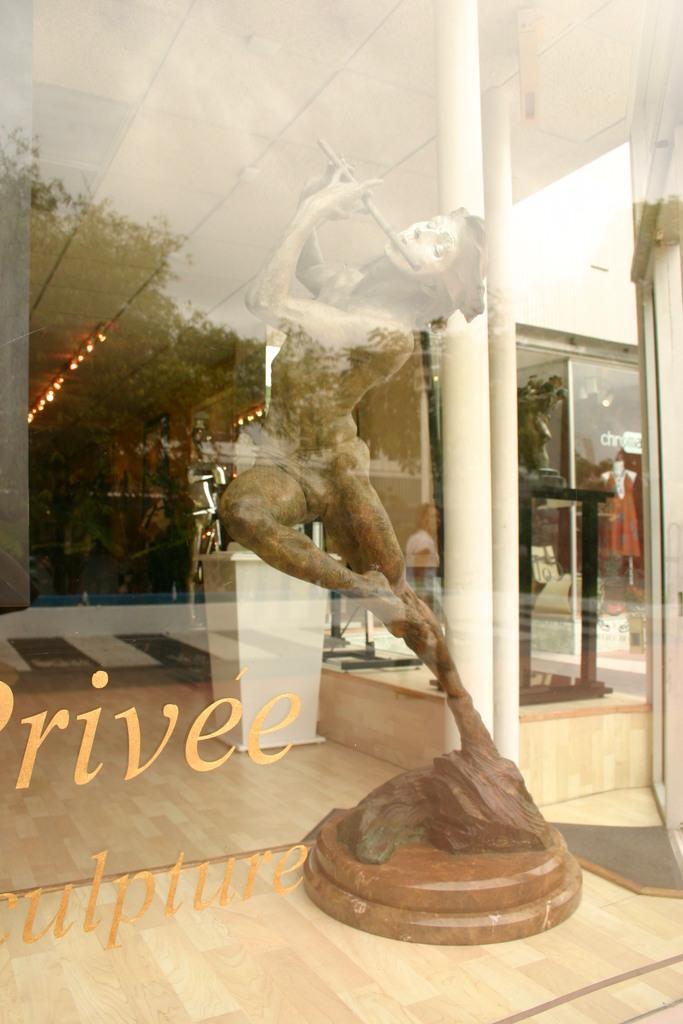Could you give a brief overview of what you see in this image? In this image, we can see a glass door and there is some text on it, through the glass we can see a sculpture, lights, a mannequin, a stand and some other objects. 